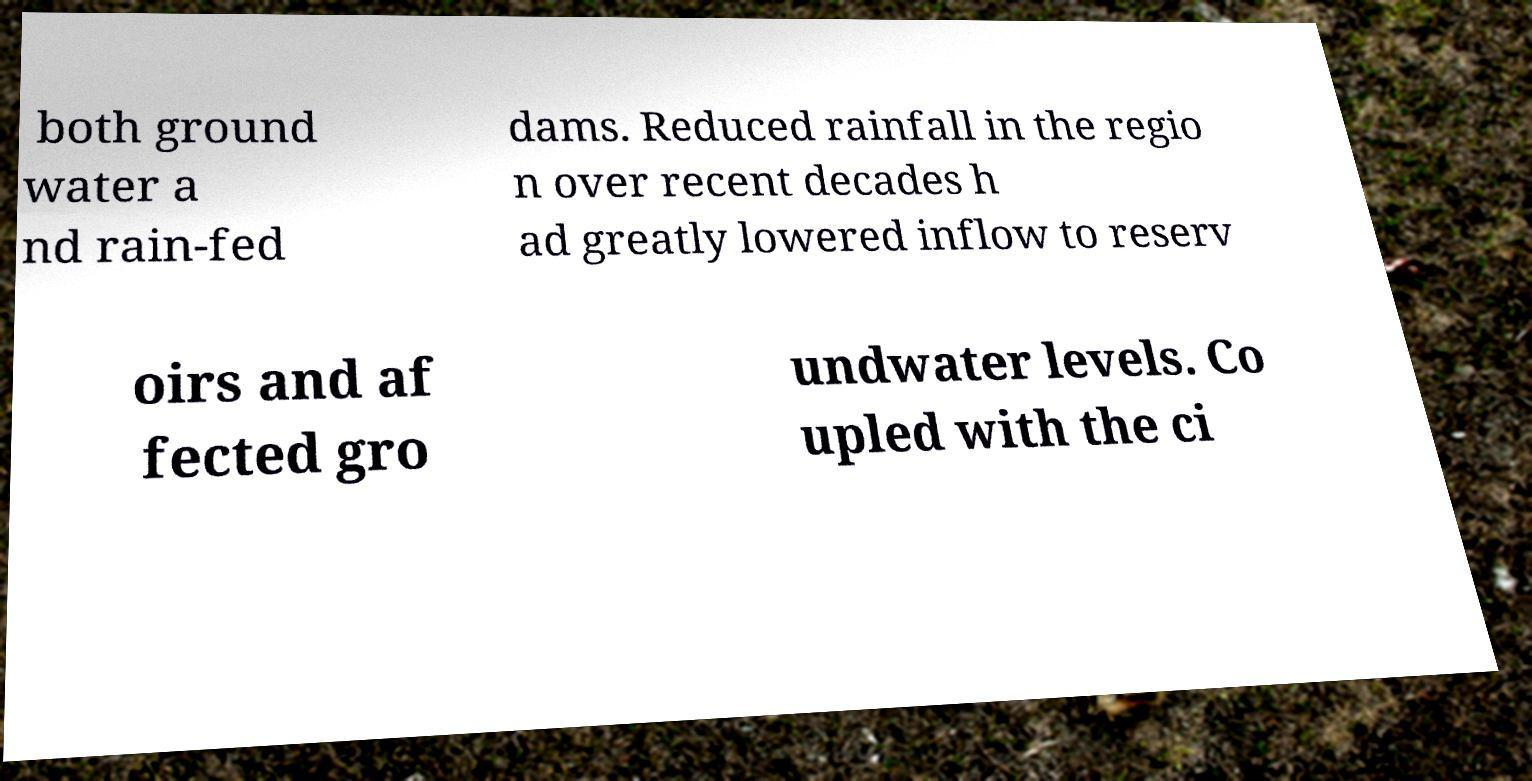What messages or text are displayed in this image? I need them in a readable, typed format. both ground water a nd rain-fed dams. Reduced rainfall in the regio n over recent decades h ad greatly lowered inflow to reserv oirs and af fected gro undwater levels. Co upled with the ci 